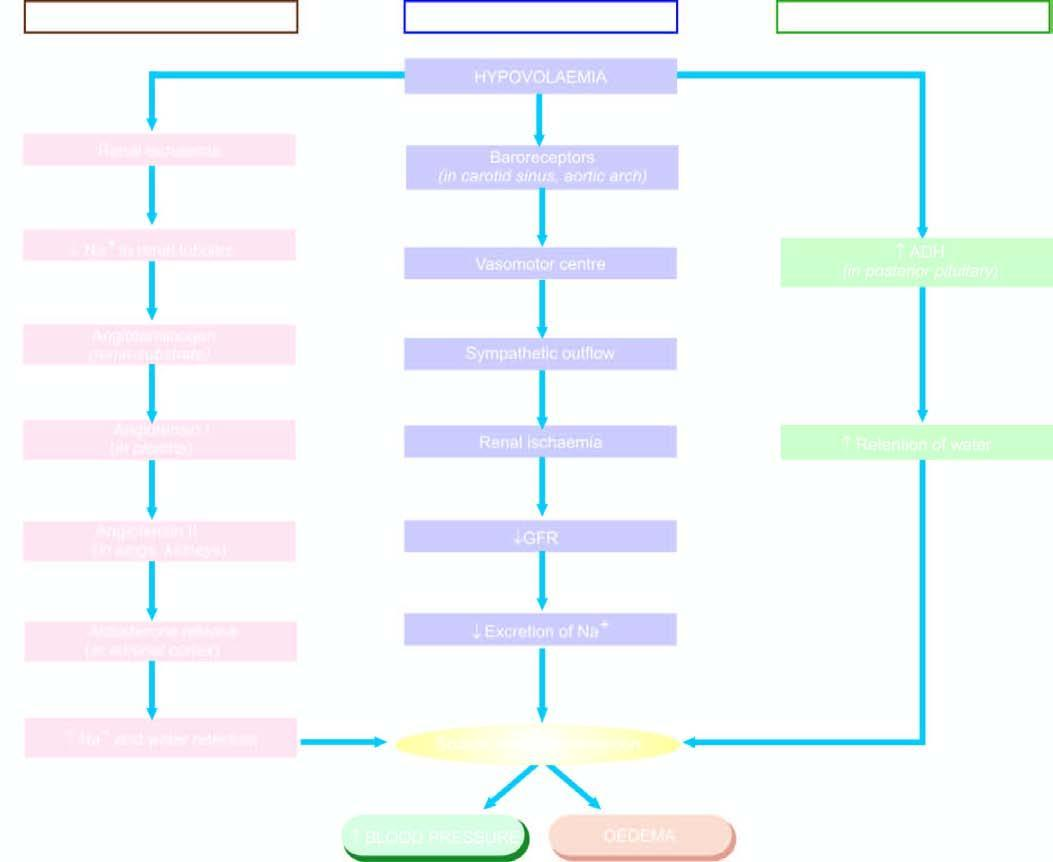what is mechanisms involved in by sodium and water retention?
Answer the question using a single word or phrase. Oedema 